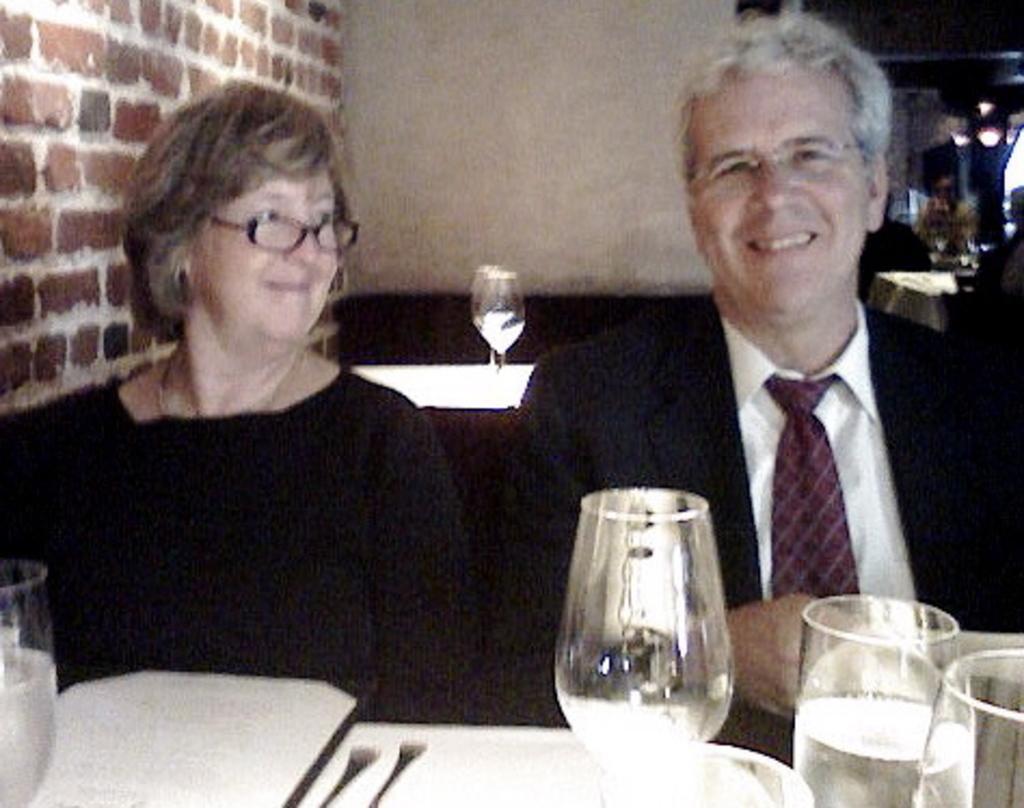Could you give a brief overview of what you see in this image? In this picture there are two persons sitting at the table. There are glasses and plates on the table. At the back there are glasses on the table and there is a wall and on the right side of the image and there are lights and there is a person sitting at the table 